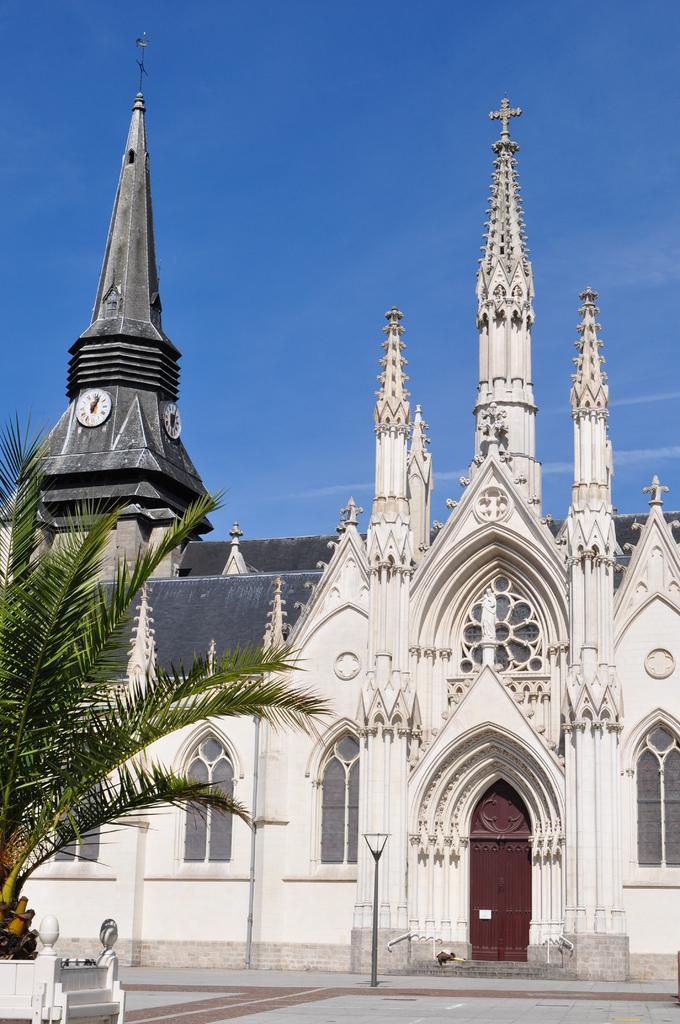In one or two sentences, can you explain what this image depicts? In this image we can see a building with door. Also there are windows. On the left side there is a tree. In the background there is sky. On the building there is a clock. In front of the building there is a light pole. 